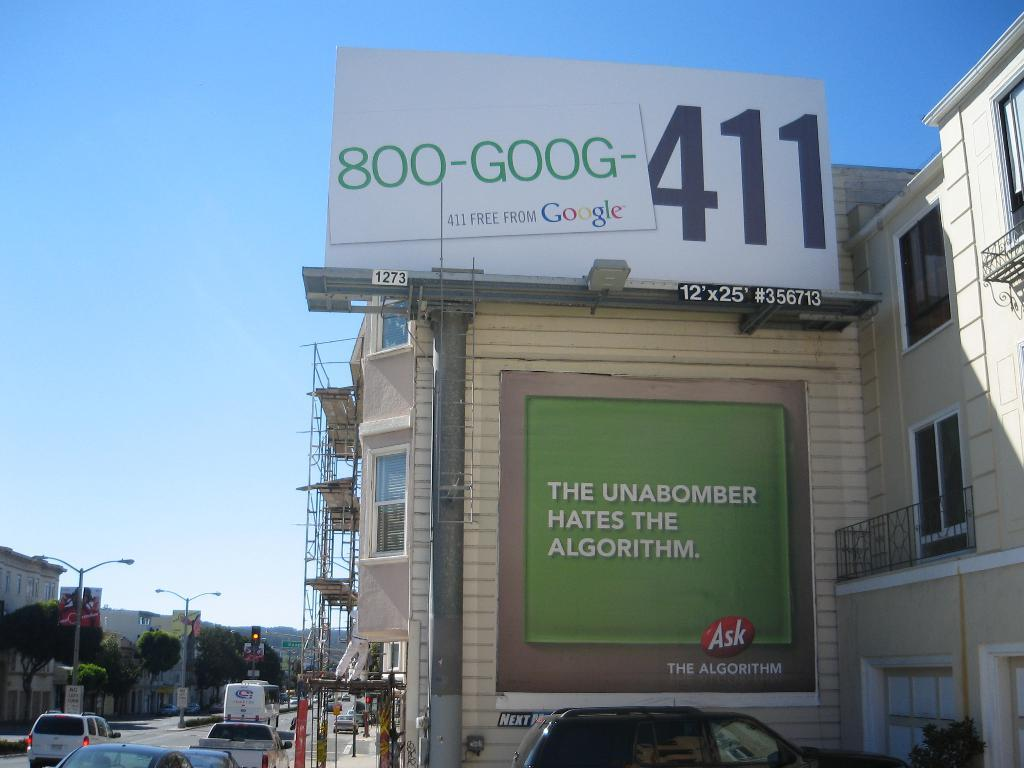Provide a one-sentence caption for the provided image. The side of a building has a sign about the unabomber and the algorithm. 